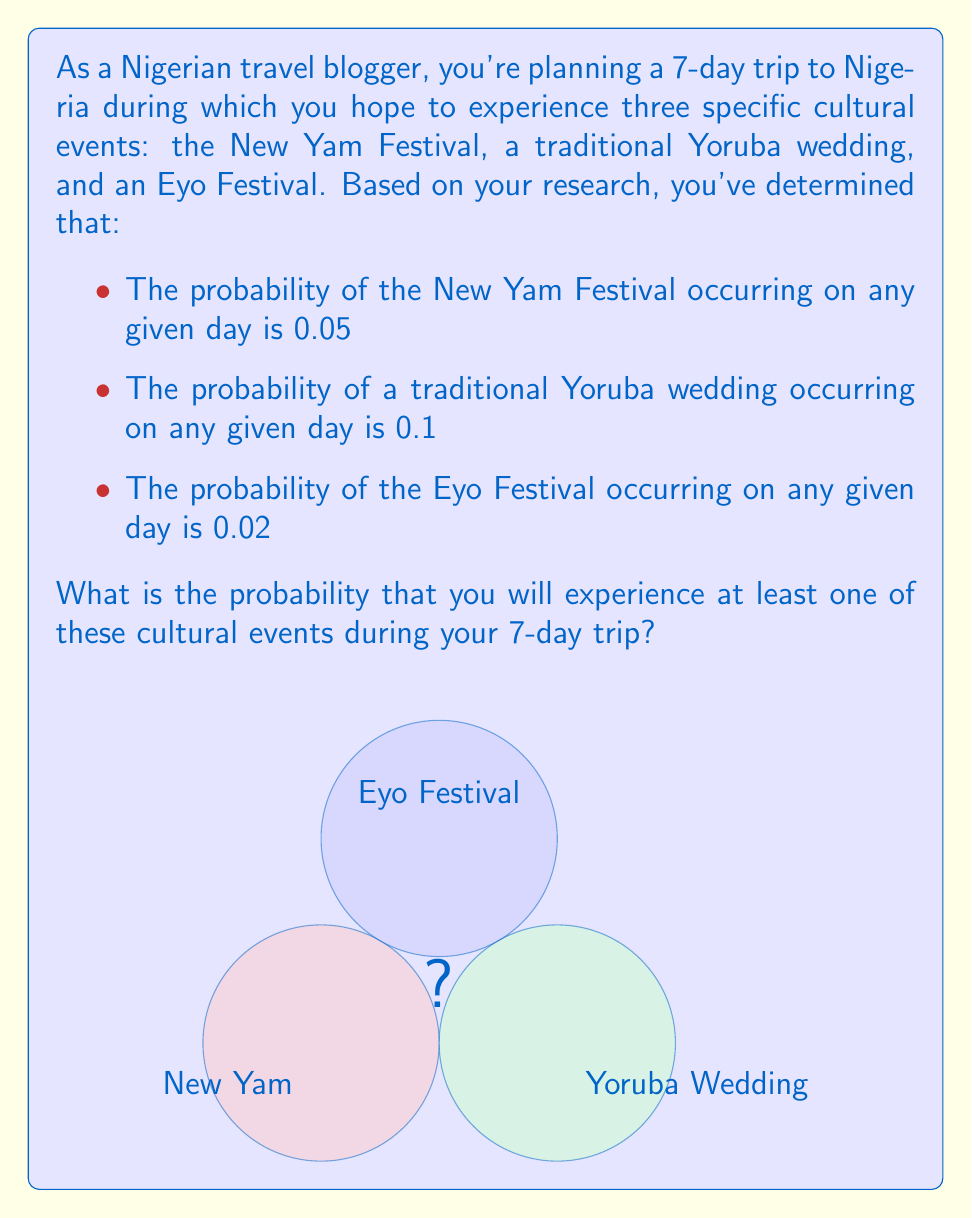Provide a solution to this math problem. Let's approach this step-by-step using probability theory:

1) First, let's calculate the probability of not experiencing each event on a single day:

   P(No New Yam) = 1 - 0.05 = 0.95
   P(No Yoruba Wedding) = 1 - 0.1 = 0.9
   P(No Eyo Festival) = 1 - 0.02 = 0.98

2) Now, for the entire 7-day trip, the probability of not experiencing each event is:

   P(No New Yam in 7 days) = $0.95^7 = 0.6983$
   P(No Yoruba Wedding in 7 days) = $0.9^7 = 0.4783$
   P(No Eyo Festival in 7 days) = $0.98^7 = 0.8686$

3) The probability of not experiencing any of these events during the 7-day trip is the product of these probabilities:

   P(No events) = $0.6983 * 0.4783 * 0.8686 = 0.2896$

4) Therefore, the probability of experiencing at least one of these events is the complement of this probability:

   P(At least one event) = 1 - P(No events) = 1 - 0.2896 = 0.7104

5) Converting to a percentage:

   0.7104 * 100 = 71.04%

Thus, there is approximately a 71.04% chance of experiencing at least one of these cultural events during the 7-day trip to Nigeria.
Answer: 71.04% 